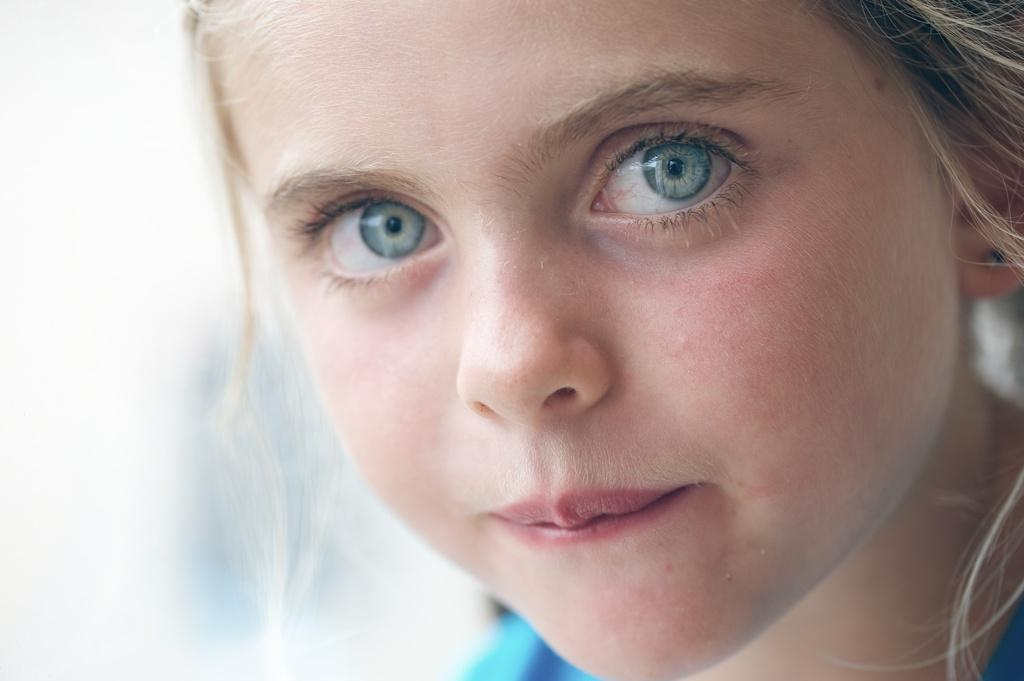What is the main subject of the image? There is a girl's face in the image. Can you describe the background of the image? The background is blurred. What type of trail can be seen in the background of the image? There is no trail visible in the image; the background is blurred. How does the heat affect the girl's face in the image? The image does not provide any information about the temperature or heat, so we cannot determine its effect on the girl's face. 